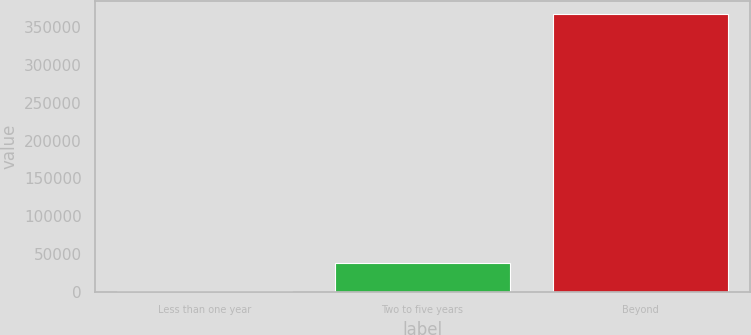Convert chart. <chart><loc_0><loc_0><loc_500><loc_500><bar_chart><fcel>Less than one year<fcel>Two to five years<fcel>Beyond<nl><fcel>1037<fcel>37601.6<fcel>366683<nl></chart> 